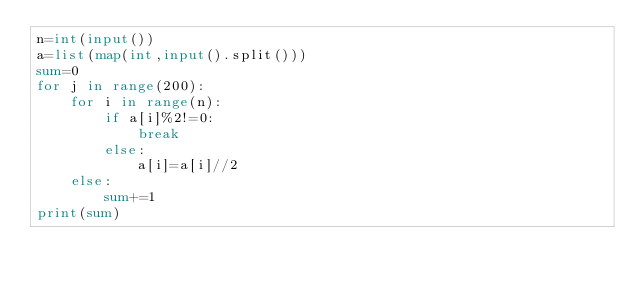Convert code to text. <code><loc_0><loc_0><loc_500><loc_500><_Python_>n=int(input())
a=list(map(int,input().split()))
sum=0
for j in range(200):
    for i in range(n):
        if a[i]%2!=0:
            break
        else:
            a[i]=a[i]//2
    else:
        sum+=1
print(sum)</code> 